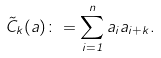Convert formula to latex. <formula><loc_0><loc_0><loc_500><loc_500>\tilde { C } _ { k } ( a ) \colon = \sum _ { i = 1 } ^ { n } a _ { i } a _ { i + k } .</formula> 